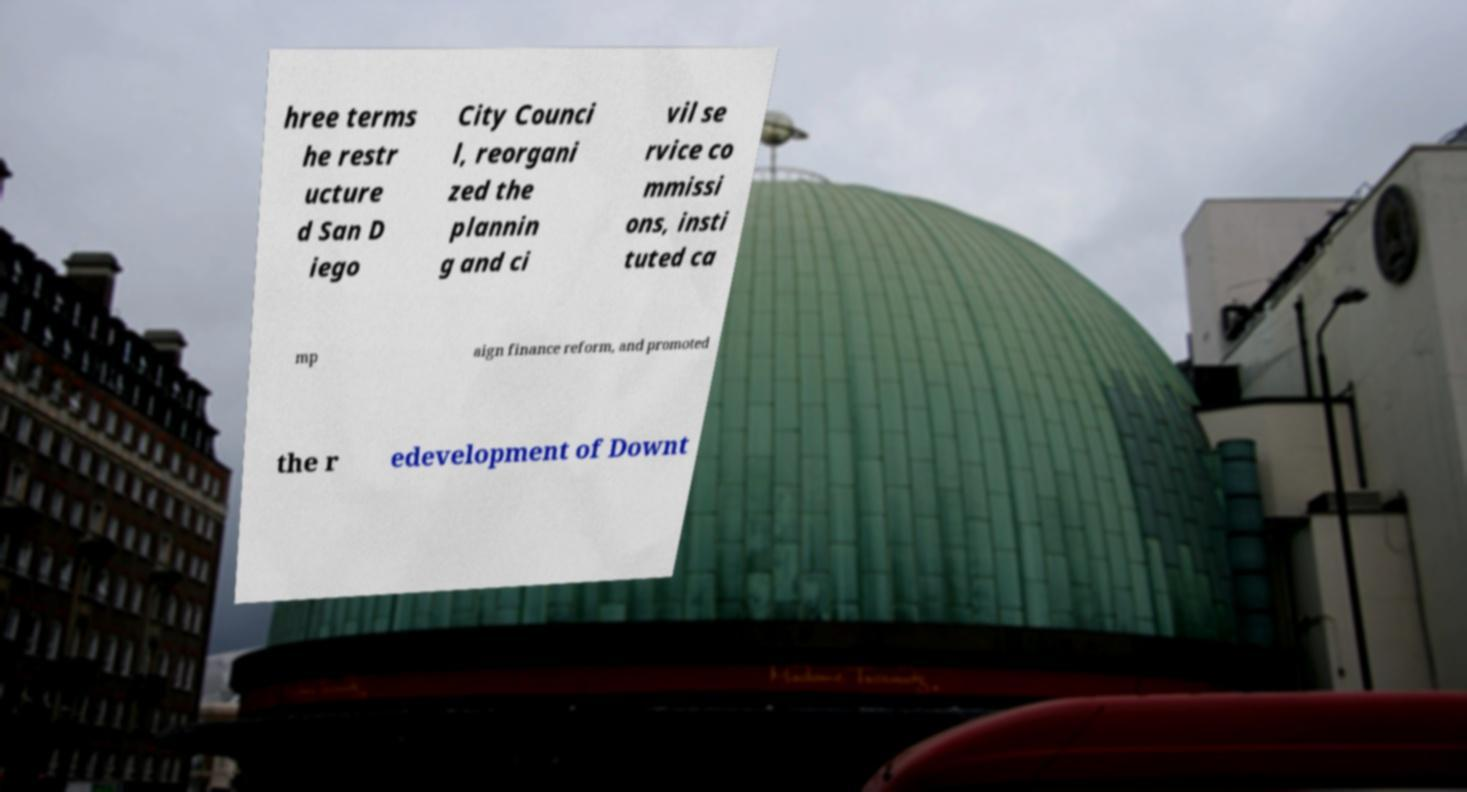For documentation purposes, I need the text within this image transcribed. Could you provide that? hree terms he restr ucture d San D iego City Counci l, reorgani zed the plannin g and ci vil se rvice co mmissi ons, insti tuted ca mp aign finance reform, and promoted the r edevelopment of Downt 